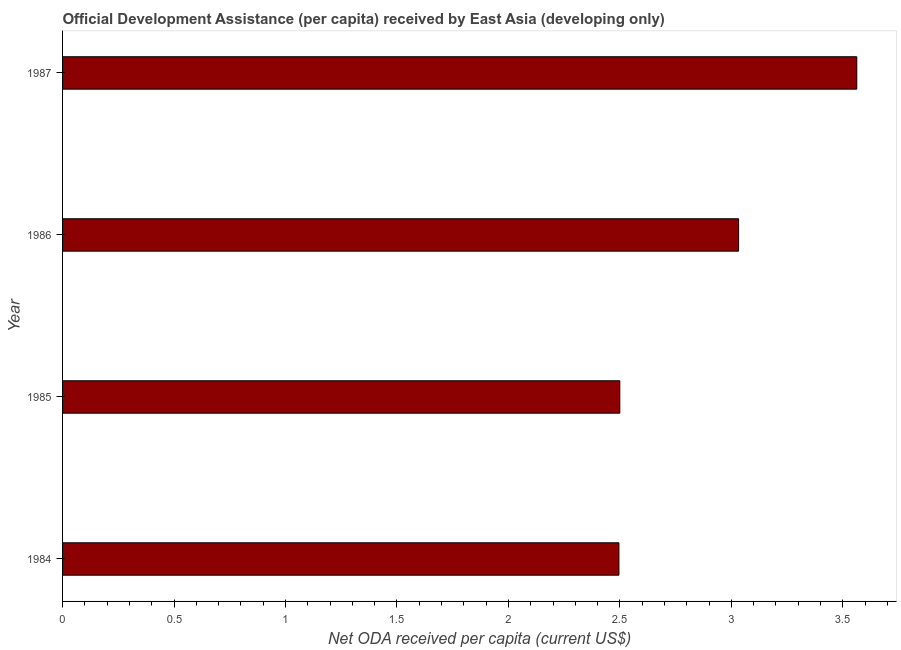Does the graph contain any zero values?
Offer a terse response. No. Does the graph contain grids?
Your answer should be very brief. No. What is the title of the graph?
Your response must be concise. Official Development Assistance (per capita) received by East Asia (developing only). What is the label or title of the X-axis?
Provide a succinct answer. Net ODA received per capita (current US$). What is the net oda received per capita in 1984?
Give a very brief answer. 2.5. Across all years, what is the maximum net oda received per capita?
Your answer should be very brief. 3.56. Across all years, what is the minimum net oda received per capita?
Offer a very short reply. 2.5. What is the sum of the net oda received per capita?
Offer a very short reply. 11.59. What is the difference between the net oda received per capita in 1984 and 1985?
Offer a very short reply. -0. What is the average net oda received per capita per year?
Provide a short and direct response. 2.9. What is the median net oda received per capita?
Provide a succinct answer. 2.77. What is the ratio of the net oda received per capita in 1984 to that in 1986?
Your response must be concise. 0.82. What is the difference between the highest and the second highest net oda received per capita?
Keep it short and to the point. 0.53. What is the difference between the highest and the lowest net oda received per capita?
Your answer should be compact. 1.07. How many bars are there?
Keep it short and to the point. 4. How many years are there in the graph?
Ensure brevity in your answer.  4. What is the Net ODA received per capita (current US$) in 1984?
Your answer should be compact. 2.5. What is the Net ODA received per capita (current US$) in 1985?
Offer a very short reply. 2.5. What is the Net ODA received per capita (current US$) in 1986?
Keep it short and to the point. 3.03. What is the Net ODA received per capita (current US$) in 1987?
Provide a short and direct response. 3.56. What is the difference between the Net ODA received per capita (current US$) in 1984 and 1985?
Provide a short and direct response. -0. What is the difference between the Net ODA received per capita (current US$) in 1984 and 1986?
Keep it short and to the point. -0.54. What is the difference between the Net ODA received per capita (current US$) in 1984 and 1987?
Make the answer very short. -1.07. What is the difference between the Net ODA received per capita (current US$) in 1985 and 1986?
Keep it short and to the point. -0.53. What is the difference between the Net ODA received per capita (current US$) in 1985 and 1987?
Offer a terse response. -1.06. What is the difference between the Net ODA received per capita (current US$) in 1986 and 1987?
Provide a succinct answer. -0.53. What is the ratio of the Net ODA received per capita (current US$) in 1984 to that in 1985?
Offer a very short reply. 1. What is the ratio of the Net ODA received per capita (current US$) in 1984 to that in 1986?
Offer a terse response. 0.82. What is the ratio of the Net ODA received per capita (current US$) in 1984 to that in 1987?
Make the answer very short. 0.7. What is the ratio of the Net ODA received per capita (current US$) in 1985 to that in 1986?
Offer a terse response. 0.82. What is the ratio of the Net ODA received per capita (current US$) in 1985 to that in 1987?
Offer a terse response. 0.7. What is the ratio of the Net ODA received per capita (current US$) in 1986 to that in 1987?
Your answer should be compact. 0.85. 